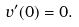<formula> <loc_0><loc_0><loc_500><loc_500>v ^ { \prime } ( 0 ) = 0 .</formula> 